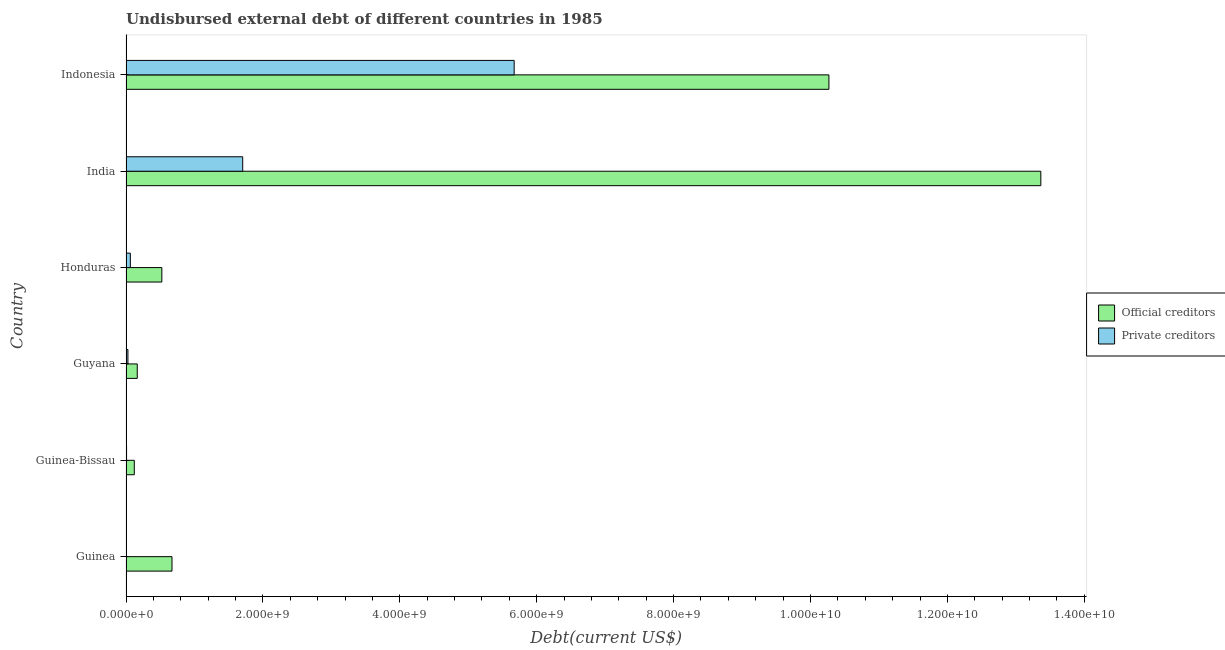How many different coloured bars are there?
Give a very brief answer. 2. How many groups of bars are there?
Make the answer very short. 6. Are the number of bars per tick equal to the number of legend labels?
Your answer should be compact. Yes. What is the label of the 5th group of bars from the top?
Give a very brief answer. Guinea-Bissau. In how many cases, is the number of bars for a given country not equal to the number of legend labels?
Your response must be concise. 0. What is the undisbursed external debt of official creditors in India?
Provide a short and direct response. 1.34e+1. Across all countries, what is the maximum undisbursed external debt of official creditors?
Your response must be concise. 1.34e+1. Across all countries, what is the minimum undisbursed external debt of private creditors?
Your answer should be very brief. 3.49e+06. In which country was the undisbursed external debt of private creditors minimum?
Make the answer very short. Guinea. What is the total undisbursed external debt of private creditors in the graph?
Make the answer very short. 7.48e+09. What is the difference between the undisbursed external debt of private creditors in Guinea-Bissau and that in Guyana?
Make the answer very short. -1.99e+07. What is the difference between the undisbursed external debt of private creditors in Indonesia and the undisbursed external debt of official creditors in India?
Offer a very short reply. -7.69e+09. What is the average undisbursed external debt of private creditors per country?
Give a very brief answer. 1.25e+09. What is the difference between the undisbursed external debt of private creditors and undisbursed external debt of official creditors in Guyana?
Offer a very short reply. -1.36e+08. What is the ratio of the undisbursed external debt of official creditors in Guyana to that in Indonesia?
Offer a terse response. 0.02. Is the undisbursed external debt of official creditors in Guinea less than that in Guinea-Bissau?
Ensure brevity in your answer.  No. Is the difference between the undisbursed external debt of official creditors in India and Indonesia greater than the difference between the undisbursed external debt of private creditors in India and Indonesia?
Offer a very short reply. Yes. What is the difference between the highest and the second highest undisbursed external debt of private creditors?
Offer a very short reply. 3.97e+09. What is the difference between the highest and the lowest undisbursed external debt of official creditors?
Offer a terse response. 1.32e+1. Is the sum of the undisbursed external debt of private creditors in Guinea-Bissau and Indonesia greater than the maximum undisbursed external debt of official creditors across all countries?
Make the answer very short. No. What does the 1st bar from the top in Indonesia represents?
Make the answer very short. Private creditors. What does the 2nd bar from the bottom in Honduras represents?
Keep it short and to the point. Private creditors. How many bars are there?
Offer a very short reply. 12. How many countries are there in the graph?
Offer a very short reply. 6. What is the difference between two consecutive major ticks on the X-axis?
Offer a very short reply. 2.00e+09. Where does the legend appear in the graph?
Ensure brevity in your answer.  Center right. What is the title of the graph?
Offer a terse response. Undisbursed external debt of different countries in 1985. What is the label or title of the X-axis?
Provide a succinct answer. Debt(current US$). What is the Debt(current US$) of Official creditors in Guinea?
Your response must be concise. 6.72e+08. What is the Debt(current US$) of Private creditors in Guinea?
Provide a succinct answer. 3.49e+06. What is the Debt(current US$) in Official creditors in Guinea-Bissau?
Give a very brief answer. 1.21e+08. What is the Debt(current US$) in Private creditors in Guinea-Bissau?
Keep it short and to the point. 7.95e+06. What is the Debt(current US$) of Official creditors in Guyana?
Your answer should be compact. 1.64e+08. What is the Debt(current US$) in Private creditors in Guyana?
Offer a very short reply. 2.79e+07. What is the Debt(current US$) in Official creditors in Honduras?
Keep it short and to the point. 5.24e+08. What is the Debt(current US$) of Private creditors in Honduras?
Give a very brief answer. 6.33e+07. What is the Debt(current US$) of Official creditors in India?
Provide a succinct answer. 1.34e+1. What is the Debt(current US$) of Private creditors in India?
Offer a very short reply. 1.70e+09. What is the Debt(current US$) of Official creditors in Indonesia?
Offer a terse response. 1.03e+1. What is the Debt(current US$) in Private creditors in Indonesia?
Give a very brief answer. 5.67e+09. Across all countries, what is the maximum Debt(current US$) of Official creditors?
Offer a very short reply. 1.34e+1. Across all countries, what is the maximum Debt(current US$) in Private creditors?
Provide a short and direct response. 5.67e+09. Across all countries, what is the minimum Debt(current US$) in Official creditors?
Your answer should be very brief. 1.21e+08. Across all countries, what is the minimum Debt(current US$) of Private creditors?
Make the answer very short. 3.49e+06. What is the total Debt(current US$) of Official creditors in the graph?
Your answer should be compact. 2.51e+1. What is the total Debt(current US$) of Private creditors in the graph?
Keep it short and to the point. 7.48e+09. What is the difference between the Debt(current US$) in Official creditors in Guinea and that in Guinea-Bissau?
Keep it short and to the point. 5.51e+08. What is the difference between the Debt(current US$) in Private creditors in Guinea and that in Guinea-Bissau?
Your answer should be very brief. -4.47e+06. What is the difference between the Debt(current US$) in Official creditors in Guinea and that in Guyana?
Give a very brief answer. 5.08e+08. What is the difference between the Debt(current US$) of Private creditors in Guinea and that in Guyana?
Give a very brief answer. -2.44e+07. What is the difference between the Debt(current US$) of Official creditors in Guinea and that in Honduras?
Keep it short and to the point. 1.48e+08. What is the difference between the Debt(current US$) in Private creditors in Guinea and that in Honduras?
Your answer should be very brief. -5.99e+07. What is the difference between the Debt(current US$) in Official creditors in Guinea and that in India?
Offer a very short reply. -1.27e+1. What is the difference between the Debt(current US$) of Private creditors in Guinea and that in India?
Your answer should be compact. -1.70e+09. What is the difference between the Debt(current US$) in Official creditors in Guinea and that in Indonesia?
Offer a terse response. -9.60e+09. What is the difference between the Debt(current US$) in Private creditors in Guinea and that in Indonesia?
Make the answer very short. -5.67e+09. What is the difference between the Debt(current US$) of Official creditors in Guinea-Bissau and that in Guyana?
Your answer should be very brief. -4.32e+07. What is the difference between the Debt(current US$) in Private creditors in Guinea-Bissau and that in Guyana?
Offer a terse response. -1.99e+07. What is the difference between the Debt(current US$) in Official creditors in Guinea-Bissau and that in Honduras?
Offer a terse response. -4.03e+08. What is the difference between the Debt(current US$) in Private creditors in Guinea-Bissau and that in Honduras?
Provide a succinct answer. -5.54e+07. What is the difference between the Debt(current US$) in Official creditors in Guinea-Bissau and that in India?
Keep it short and to the point. -1.32e+1. What is the difference between the Debt(current US$) of Private creditors in Guinea-Bissau and that in India?
Offer a terse response. -1.70e+09. What is the difference between the Debt(current US$) of Official creditors in Guinea-Bissau and that in Indonesia?
Your answer should be very brief. -1.01e+1. What is the difference between the Debt(current US$) of Private creditors in Guinea-Bissau and that in Indonesia?
Offer a terse response. -5.66e+09. What is the difference between the Debt(current US$) in Official creditors in Guyana and that in Honduras?
Provide a short and direct response. -3.59e+08. What is the difference between the Debt(current US$) of Private creditors in Guyana and that in Honduras?
Keep it short and to the point. -3.55e+07. What is the difference between the Debt(current US$) in Official creditors in Guyana and that in India?
Your answer should be compact. -1.32e+1. What is the difference between the Debt(current US$) of Private creditors in Guyana and that in India?
Your answer should be very brief. -1.68e+09. What is the difference between the Debt(current US$) in Official creditors in Guyana and that in Indonesia?
Give a very brief answer. -1.01e+1. What is the difference between the Debt(current US$) in Private creditors in Guyana and that in Indonesia?
Your answer should be compact. -5.64e+09. What is the difference between the Debt(current US$) in Official creditors in Honduras and that in India?
Make the answer very short. -1.28e+1. What is the difference between the Debt(current US$) of Private creditors in Honduras and that in India?
Offer a very short reply. -1.64e+09. What is the difference between the Debt(current US$) of Official creditors in Honduras and that in Indonesia?
Keep it short and to the point. -9.75e+09. What is the difference between the Debt(current US$) of Private creditors in Honduras and that in Indonesia?
Your answer should be very brief. -5.61e+09. What is the difference between the Debt(current US$) of Official creditors in India and that in Indonesia?
Make the answer very short. 3.10e+09. What is the difference between the Debt(current US$) in Private creditors in India and that in Indonesia?
Your response must be concise. -3.97e+09. What is the difference between the Debt(current US$) in Official creditors in Guinea and the Debt(current US$) in Private creditors in Guinea-Bissau?
Ensure brevity in your answer.  6.64e+08. What is the difference between the Debt(current US$) of Official creditors in Guinea and the Debt(current US$) of Private creditors in Guyana?
Your answer should be compact. 6.44e+08. What is the difference between the Debt(current US$) of Official creditors in Guinea and the Debt(current US$) of Private creditors in Honduras?
Offer a terse response. 6.08e+08. What is the difference between the Debt(current US$) in Official creditors in Guinea and the Debt(current US$) in Private creditors in India?
Offer a very short reply. -1.03e+09. What is the difference between the Debt(current US$) of Official creditors in Guinea and the Debt(current US$) of Private creditors in Indonesia?
Ensure brevity in your answer.  -5.00e+09. What is the difference between the Debt(current US$) in Official creditors in Guinea-Bissau and the Debt(current US$) in Private creditors in Guyana?
Provide a succinct answer. 9.31e+07. What is the difference between the Debt(current US$) of Official creditors in Guinea-Bissau and the Debt(current US$) of Private creditors in Honduras?
Make the answer very short. 5.76e+07. What is the difference between the Debt(current US$) in Official creditors in Guinea-Bissau and the Debt(current US$) in Private creditors in India?
Give a very brief answer. -1.58e+09. What is the difference between the Debt(current US$) of Official creditors in Guinea-Bissau and the Debt(current US$) of Private creditors in Indonesia?
Provide a succinct answer. -5.55e+09. What is the difference between the Debt(current US$) in Official creditors in Guyana and the Debt(current US$) in Private creditors in Honduras?
Offer a very short reply. 1.01e+08. What is the difference between the Debt(current US$) in Official creditors in Guyana and the Debt(current US$) in Private creditors in India?
Your answer should be very brief. -1.54e+09. What is the difference between the Debt(current US$) of Official creditors in Guyana and the Debt(current US$) of Private creditors in Indonesia?
Make the answer very short. -5.51e+09. What is the difference between the Debt(current US$) in Official creditors in Honduras and the Debt(current US$) in Private creditors in India?
Give a very brief answer. -1.18e+09. What is the difference between the Debt(current US$) of Official creditors in Honduras and the Debt(current US$) of Private creditors in Indonesia?
Make the answer very short. -5.15e+09. What is the difference between the Debt(current US$) in Official creditors in India and the Debt(current US$) in Private creditors in Indonesia?
Your answer should be compact. 7.69e+09. What is the average Debt(current US$) in Official creditors per country?
Give a very brief answer. 4.19e+09. What is the average Debt(current US$) of Private creditors per country?
Give a very brief answer. 1.25e+09. What is the difference between the Debt(current US$) in Official creditors and Debt(current US$) in Private creditors in Guinea?
Your answer should be compact. 6.68e+08. What is the difference between the Debt(current US$) in Official creditors and Debt(current US$) in Private creditors in Guinea-Bissau?
Provide a short and direct response. 1.13e+08. What is the difference between the Debt(current US$) of Official creditors and Debt(current US$) of Private creditors in Guyana?
Offer a terse response. 1.36e+08. What is the difference between the Debt(current US$) in Official creditors and Debt(current US$) in Private creditors in Honduras?
Offer a terse response. 4.60e+08. What is the difference between the Debt(current US$) of Official creditors and Debt(current US$) of Private creditors in India?
Keep it short and to the point. 1.17e+1. What is the difference between the Debt(current US$) of Official creditors and Debt(current US$) of Private creditors in Indonesia?
Provide a short and direct response. 4.60e+09. What is the ratio of the Debt(current US$) in Official creditors in Guinea to that in Guinea-Bissau?
Offer a terse response. 5.55. What is the ratio of the Debt(current US$) of Private creditors in Guinea to that in Guinea-Bissau?
Your response must be concise. 0.44. What is the ratio of the Debt(current US$) of Official creditors in Guinea to that in Guyana?
Provide a short and direct response. 4.09. What is the ratio of the Debt(current US$) in Private creditors in Guinea to that in Guyana?
Offer a very short reply. 0.13. What is the ratio of the Debt(current US$) of Official creditors in Guinea to that in Honduras?
Give a very brief answer. 1.28. What is the ratio of the Debt(current US$) of Private creditors in Guinea to that in Honduras?
Make the answer very short. 0.06. What is the ratio of the Debt(current US$) of Official creditors in Guinea to that in India?
Your answer should be very brief. 0.05. What is the ratio of the Debt(current US$) in Private creditors in Guinea to that in India?
Keep it short and to the point. 0. What is the ratio of the Debt(current US$) of Official creditors in Guinea to that in Indonesia?
Ensure brevity in your answer.  0.07. What is the ratio of the Debt(current US$) in Private creditors in Guinea to that in Indonesia?
Make the answer very short. 0. What is the ratio of the Debt(current US$) of Official creditors in Guinea-Bissau to that in Guyana?
Offer a terse response. 0.74. What is the ratio of the Debt(current US$) in Private creditors in Guinea-Bissau to that in Guyana?
Offer a very short reply. 0.29. What is the ratio of the Debt(current US$) in Official creditors in Guinea-Bissau to that in Honduras?
Keep it short and to the point. 0.23. What is the ratio of the Debt(current US$) of Private creditors in Guinea-Bissau to that in Honduras?
Offer a very short reply. 0.13. What is the ratio of the Debt(current US$) in Official creditors in Guinea-Bissau to that in India?
Make the answer very short. 0.01. What is the ratio of the Debt(current US$) in Private creditors in Guinea-Bissau to that in India?
Offer a terse response. 0. What is the ratio of the Debt(current US$) in Official creditors in Guinea-Bissau to that in Indonesia?
Your answer should be very brief. 0.01. What is the ratio of the Debt(current US$) in Private creditors in Guinea-Bissau to that in Indonesia?
Your response must be concise. 0. What is the ratio of the Debt(current US$) of Official creditors in Guyana to that in Honduras?
Give a very brief answer. 0.31. What is the ratio of the Debt(current US$) of Private creditors in Guyana to that in Honduras?
Your answer should be compact. 0.44. What is the ratio of the Debt(current US$) in Official creditors in Guyana to that in India?
Give a very brief answer. 0.01. What is the ratio of the Debt(current US$) in Private creditors in Guyana to that in India?
Offer a terse response. 0.02. What is the ratio of the Debt(current US$) of Official creditors in Guyana to that in Indonesia?
Make the answer very short. 0.02. What is the ratio of the Debt(current US$) in Private creditors in Guyana to that in Indonesia?
Ensure brevity in your answer.  0. What is the ratio of the Debt(current US$) of Official creditors in Honduras to that in India?
Provide a succinct answer. 0.04. What is the ratio of the Debt(current US$) in Private creditors in Honduras to that in India?
Your response must be concise. 0.04. What is the ratio of the Debt(current US$) in Official creditors in Honduras to that in Indonesia?
Ensure brevity in your answer.  0.05. What is the ratio of the Debt(current US$) in Private creditors in Honduras to that in Indonesia?
Provide a succinct answer. 0.01. What is the ratio of the Debt(current US$) in Official creditors in India to that in Indonesia?
Keep it short and to the point. 1.3. What is the ratio of the Debt(current US$) in Private creditors in India to that in Indonesia?
Give a very brief answer. 0.3. What is the difference between the highest and the second highest Debt(current US$) of Official creditors?
Keep it short and to the point. 3.10e+09. What is the difference between the highest and the second highest Debt(current US$) in Private creditors?
Provide a succinct answer. 3.97e+09. What is the difference between the highest and the lowest Debt(current US$) in Official creditors?
Give a very brief answer. 1.32e+1. What is the difference between the highest and the lowest Debt(current US$) of Private creditors?
Make the answer very short. 5.67e+09. 